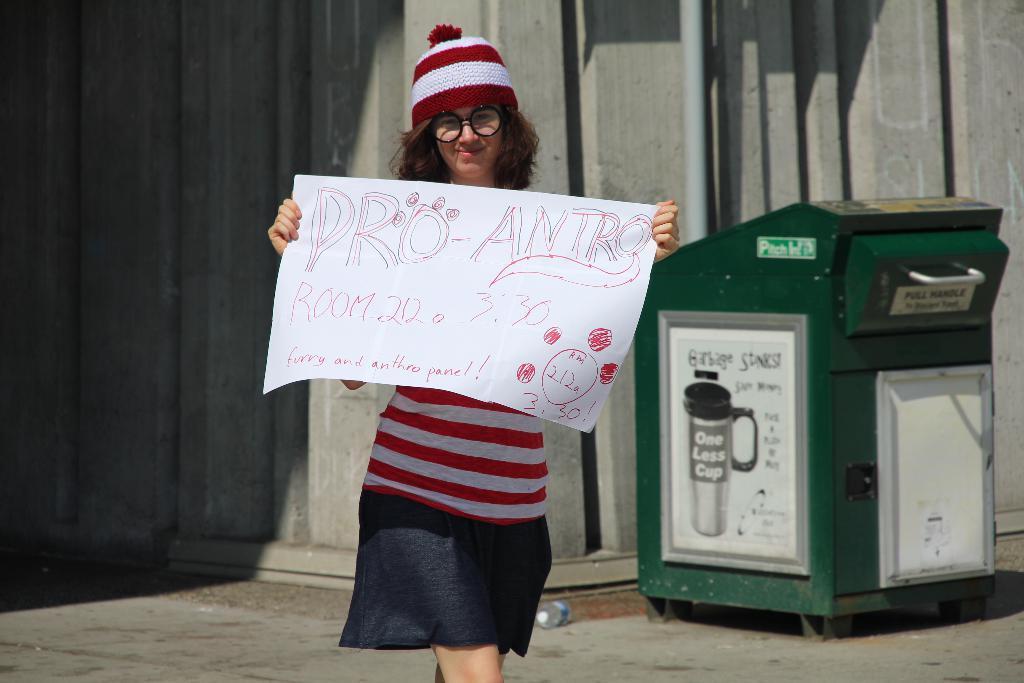Could you give a brief overview of what you see in this image? In this image I can see a woman is holding a poster in hand. In the background I can see a wall, pipe and a box. This image is taken on the road. 